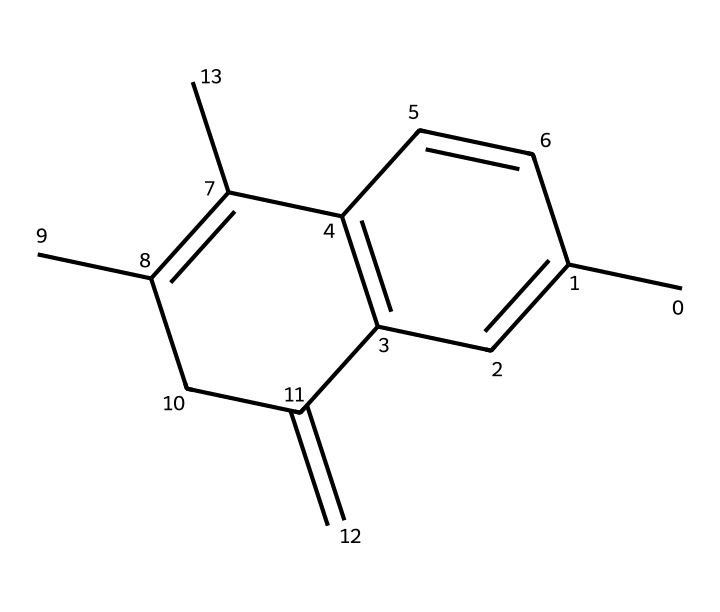What is the molecular formula of the compound represented by the SMILES? The SMILES notation indicates the structure of the compound, allowing us to determine the molecular formula by counting the carbon (C) and hydrogen (H) atoms. In this case, the structure consists of 15 carbon and 18 hydrogen atoms.
Answer: C15H18 How many rings are present in the structure? By analyzing the structure derived from the SMILES, we can identify multiple closed loops where carbon atoms bond back to themselves. The given chemical has two aromatic rings formed in its structure.
Answer: 2 What type of hybridization do the carbon atoms exhibit in this compound? The carbon atoms in the aromatic rings are typically sp2 hybridized due to their involvement in double bonds, suggesting a planar structure. By looking at the arrangement of the rings and connections, we conclude that the predominant hybridization here is sp2.
Answer: sp2 Does the structure contain any functional groups? A careful look at the SMILES structure suggests it is mainly composed of hydrocarbon chains and rings; however, it does not showcase any identifiable functional groups such as -OH or -COOH groups. Thus, there are no functional groups present in this chemical.
Answer: No What is the predicted state of this compound at room temperature? The compound's structure indicates a relatively low molecular weight and the presence of non-polar aromatic rings, which usually leads to volatility and a gaseous state in this type of compound at room temperature; hence, it is predicted to be a gas.
Answer: Gas 